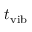<formula> <loc_0><loc_0><loc_500><loc_500>t _ { v i b }</formula> 